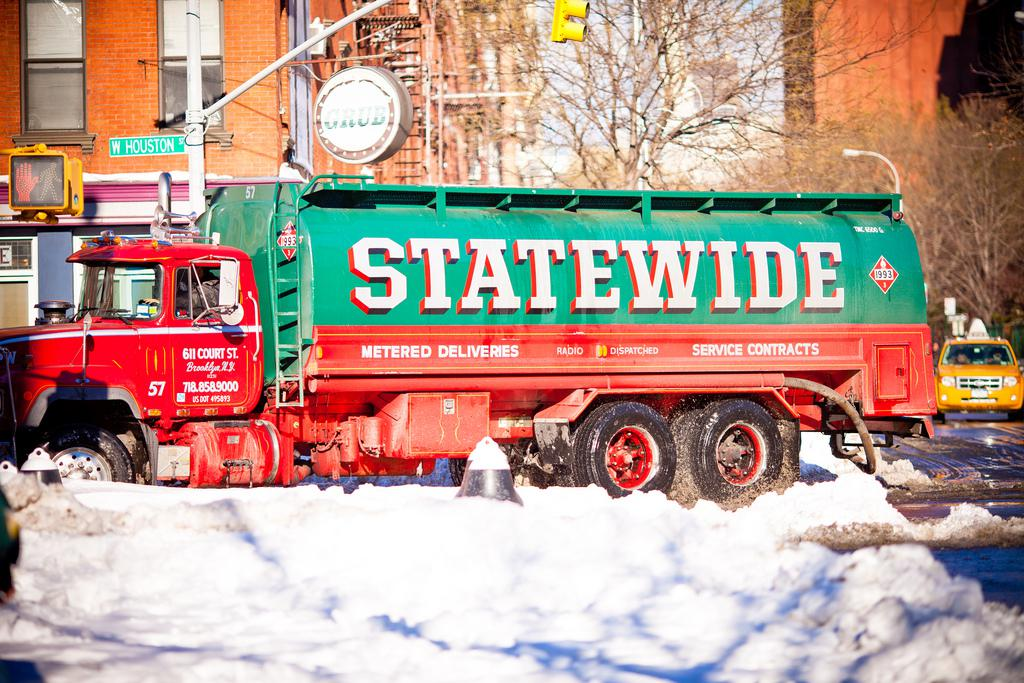Question: what is on the ground?
Choices:
A. Water.
B. Gravel.
C. Dirt.
D. Snow.
Answer with the letter. Answer: D Question: where does the taxi drive?
Choices:
A. Down the street.
B. Over a hill.
C. Under a bridge.
D. To the airport.
Answer with the letter. Answer: A Question: what vehicle is this?
Choices:
A. Car.
B. Bus.
C. Plane.
D. Truck.
Answer with the letter. Answer: D Question: when was the photo taken?
Choices:
A. Morning.
B. During the day.
C. Evening.
D. Night time.
Answer with the letter. Answer: B Question: what state are the trees in?
Choices:
A. Sleeveless dress.
B. Strap less dress.
C. Bare of sleeves.
D. Bare arm dress.
Answer with the letter. Answer: C Question: what is written on the red truck?
Choices:
A. Mandatory.
B. STATEWIDE.
C. Obligatory.
D. Involuntary.
Answer with the letter. Answer: B Question: what color are the street lights?
Choices:
A. White.
B. Red.
C. Green.
D. Yellowish.
Answer with the letter. Answer: D Question: what does the truck say?
Choices:
A. Statewide.
B. Nationwide.
C. International.
D. Locally owned.
Answer with the letter. Answer: A Question: what is the weather?
Choices:
A. Sunny.
B. Cloudy.
C. Windy.
D. Rainy.
Answer with the letter. Answer: A Question: why was the photo taken?
Choices:
A. To provide advertisement.
B. To show the background.
C. For selling purposes.
D. To show the truck.
Answer with the letter. Answer: D Question: who drives the truck?
Choices:
A. A woman.
B. A post office worker.
C. A fireman.
D. A delivery man.
Answer with the letter. Answer: D Question: how is the truck?
Choices:
A. Large.
B. Eight wheels.
C. Red and green.
D. A delivery truck.
Answer with the letter. Answer: C Question: what street is the tanker driving on?
Choices:
A. W Houston St.
B. Tanks driving on Houston st.
C. Tanks traveling on Houston st.
D. Tanks moving along on Houston st.
Answer with the letter. Answer: A Question: where are the shadows?
Choices:
A. On the snow.
B. In the blizzard.
C. On the snowy landscape.
D. In the snow.
Answer with the letter. Answer: D Question: what shape is a white sign?
Choices:
A. A circle.
B. Sphere.
C. A ring.
D. A disk.
Answer with the letter. Answer: A Question: what state is the tree behind the tanker truck?
Choices:
A. Leafless.
B. Bare.
C. Naked.
D. Twiggy.
Answer with the letter. Answer: A 